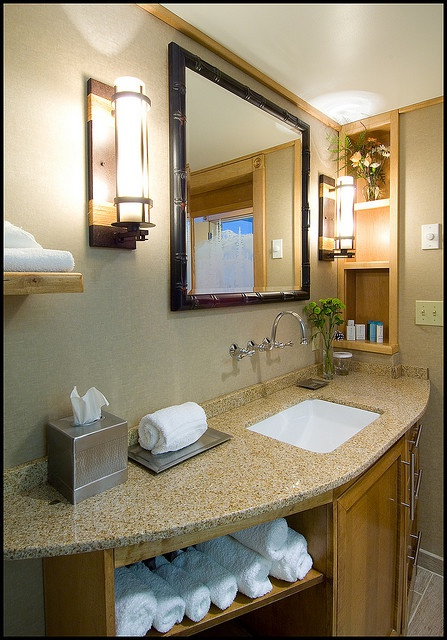Describe the objects in this image and their specific colors. I can see sink in black, lightgray, tan, and olive tones, potted plant in black, olive, tan, and maroon tones, potted plant in black, olive, gray, and darkgreen tones, vase in black, olive, and gray tones, and cup in black, gray, and darkgray tones in this image. 